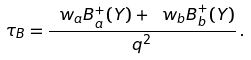<formula> <loc_0><loc_0><loc_500><loc_500>\tau _ { B } = \frac { \ w _ { a } B _ { a } ^ { + } ( Y ) + \ w _ { b } B _ { b } ^ { + } ( Y ) } { q ^ { 2 } } \, .</formula> 